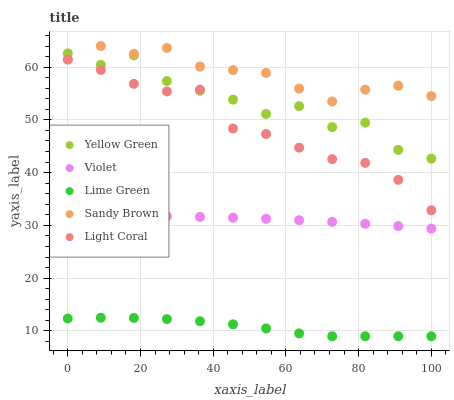Does Lime Green have the minimum area under the curve?
Answer yes or no. Yes. Does Sandy Brown have the maximum area under the curve?
Answer yes or no. Yes. Does Sandy Brown have the minimum area under the curve?
Answer yes or no. No. Does Lime Green have the maximum area under the curve?
Answer yes or no. No. Is Violet the smoothest?
Answer yes or no. Yes. Is Yellow Green the roughest?
Answer yes or no. Yes. Is Sandy Brown the smoothest?
Answer yes or no. No. Is Sandy Brown the roughest?
Answer yes or no. No. Does Lime Green have the lowest value?
Answer yes or no. Yes. Does Sandy Brown have the lowest value?
Answer yes or no. No. Does Sandy Brown have the highest value?
Answer yes or no. Yes. Does Lime Green have the highest value?
Answer yes or no. No. Is Violet less than Yellow Green?
Answer yes or no. Yes. Is Light Coral greater than Lime Green?
Answer yes or no. Yes. Does Sandy Brown intersect Yellow Green?
Answer yes or no. Yes. Is Sandy Brown less than Yellow Green?
Answer yes or no. No. Is Sandy Brown greater than Yellow Green?
Answer yes or no. No. Does Violet intersect Yellow Green?
Answer yes or no. No. 